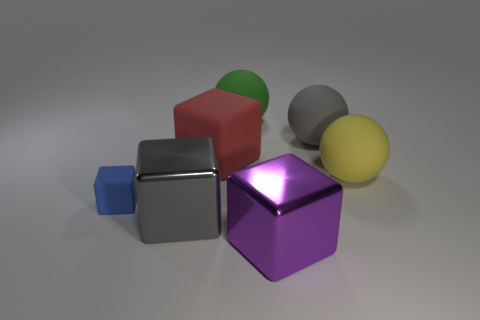What is the large gray cube made of?
Provide a short and direct response. Metal. How many other things are the same shape as the large green rubber object?
Provide a short and direct response. 2. Does the blue rubber object have the same shape as the yellow rubber object?
Keep it short and to the point. No. How many objects are either big metal cubes that are to the right of the tiny matte thing or small rubber things that are on the left side of the red object?
Provide a short and direct response. 3. How many objects are either large gray shiny things or small red metallic cubes?
Your response must be concise. 1. There is a red thing right of the blue rubber thing; how many big rubber objects are on the left side of it?
Your answer should be compact. 0. How many other objects are there of the same size as the blue cube?
Give a very brief answer. 0. Do the gray thing that is behind the blue cube and the large red matte thing have the same shape?
Ensure brevity in your answer.  No. What is the material of the block that is to the right of the red block?
Offer a very short reply. Metal. Are there any gray objects made of the same material as the large purple thing?
Give a very brief answer. Yes. 